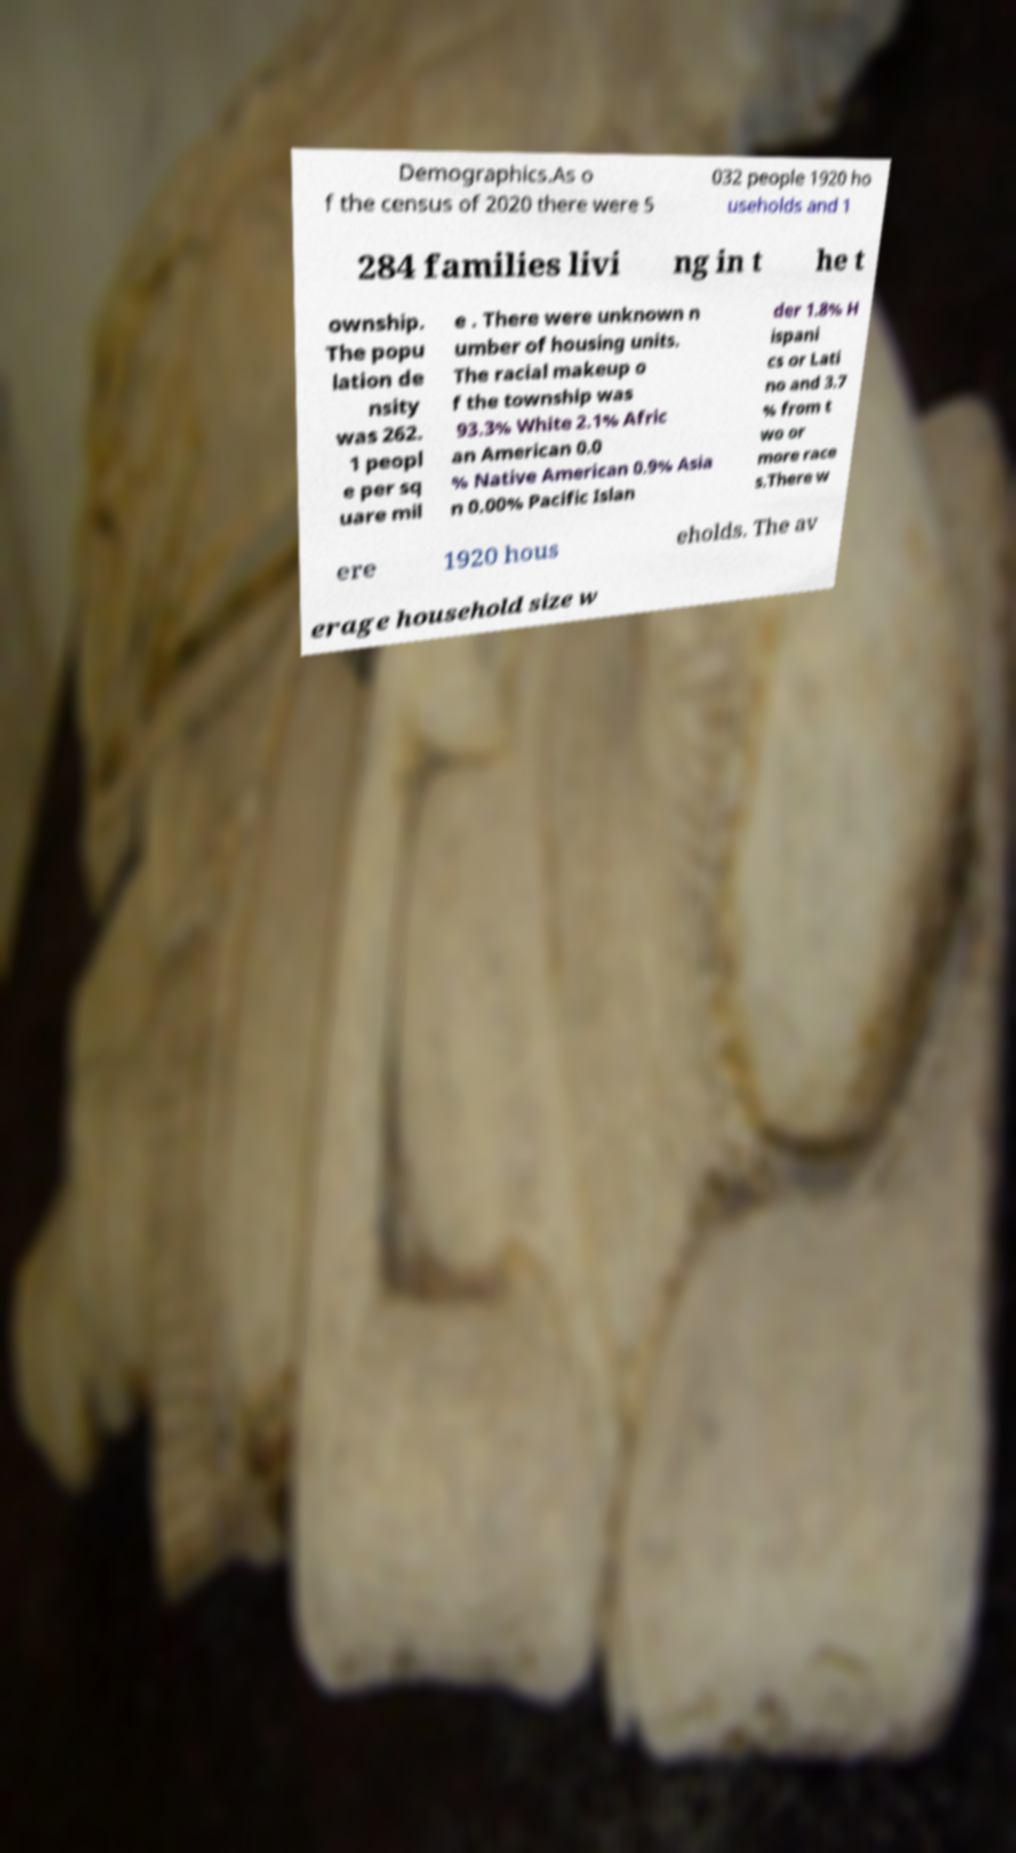Could you assist in decoding the text presented in this image and type it out clearly? Demographics.As o f the census of 2020 there were 5 032 people 1920 ho useholds and 1 284 families livi ng in t he t ownship. The popu lation de nsity was 262. 1 peopl e per sq uare mil e . There were unknown n umber of housing units. The racial makeup o f the township was 93.3% White 2.1% Afric an American 0.0 % Native American 0.9% Asia n 0.00% Pacific Islan der 1.8% H ispani cs or Lati no and 3.7 % from t wo or more race s.There w ere 1920 hous eholds. The av erage household size w 